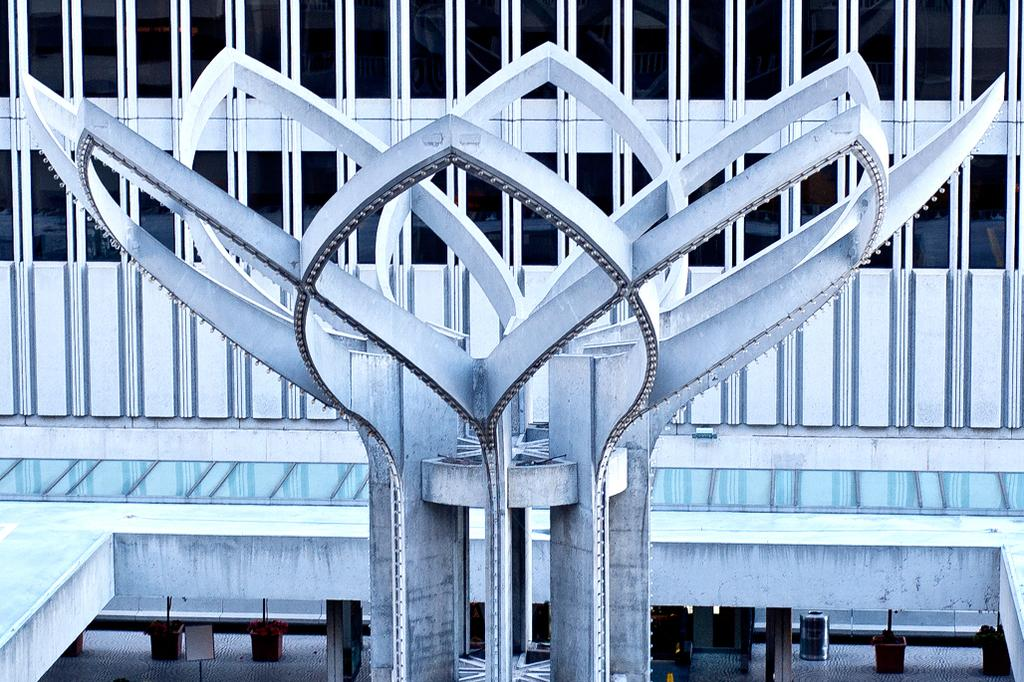What is the main subject of the image? There is a sculpture in the image. What shape is the sculpture? The sculpture is in the shape of a flower. What can be seen behind the sculpture? There are grills visible behind the sculpture. What type of disease is affecting the flower sculpture in the image? There is no mention of any disease affecting the flower sculpture in the image. The sculpture appears to be in good condition. 